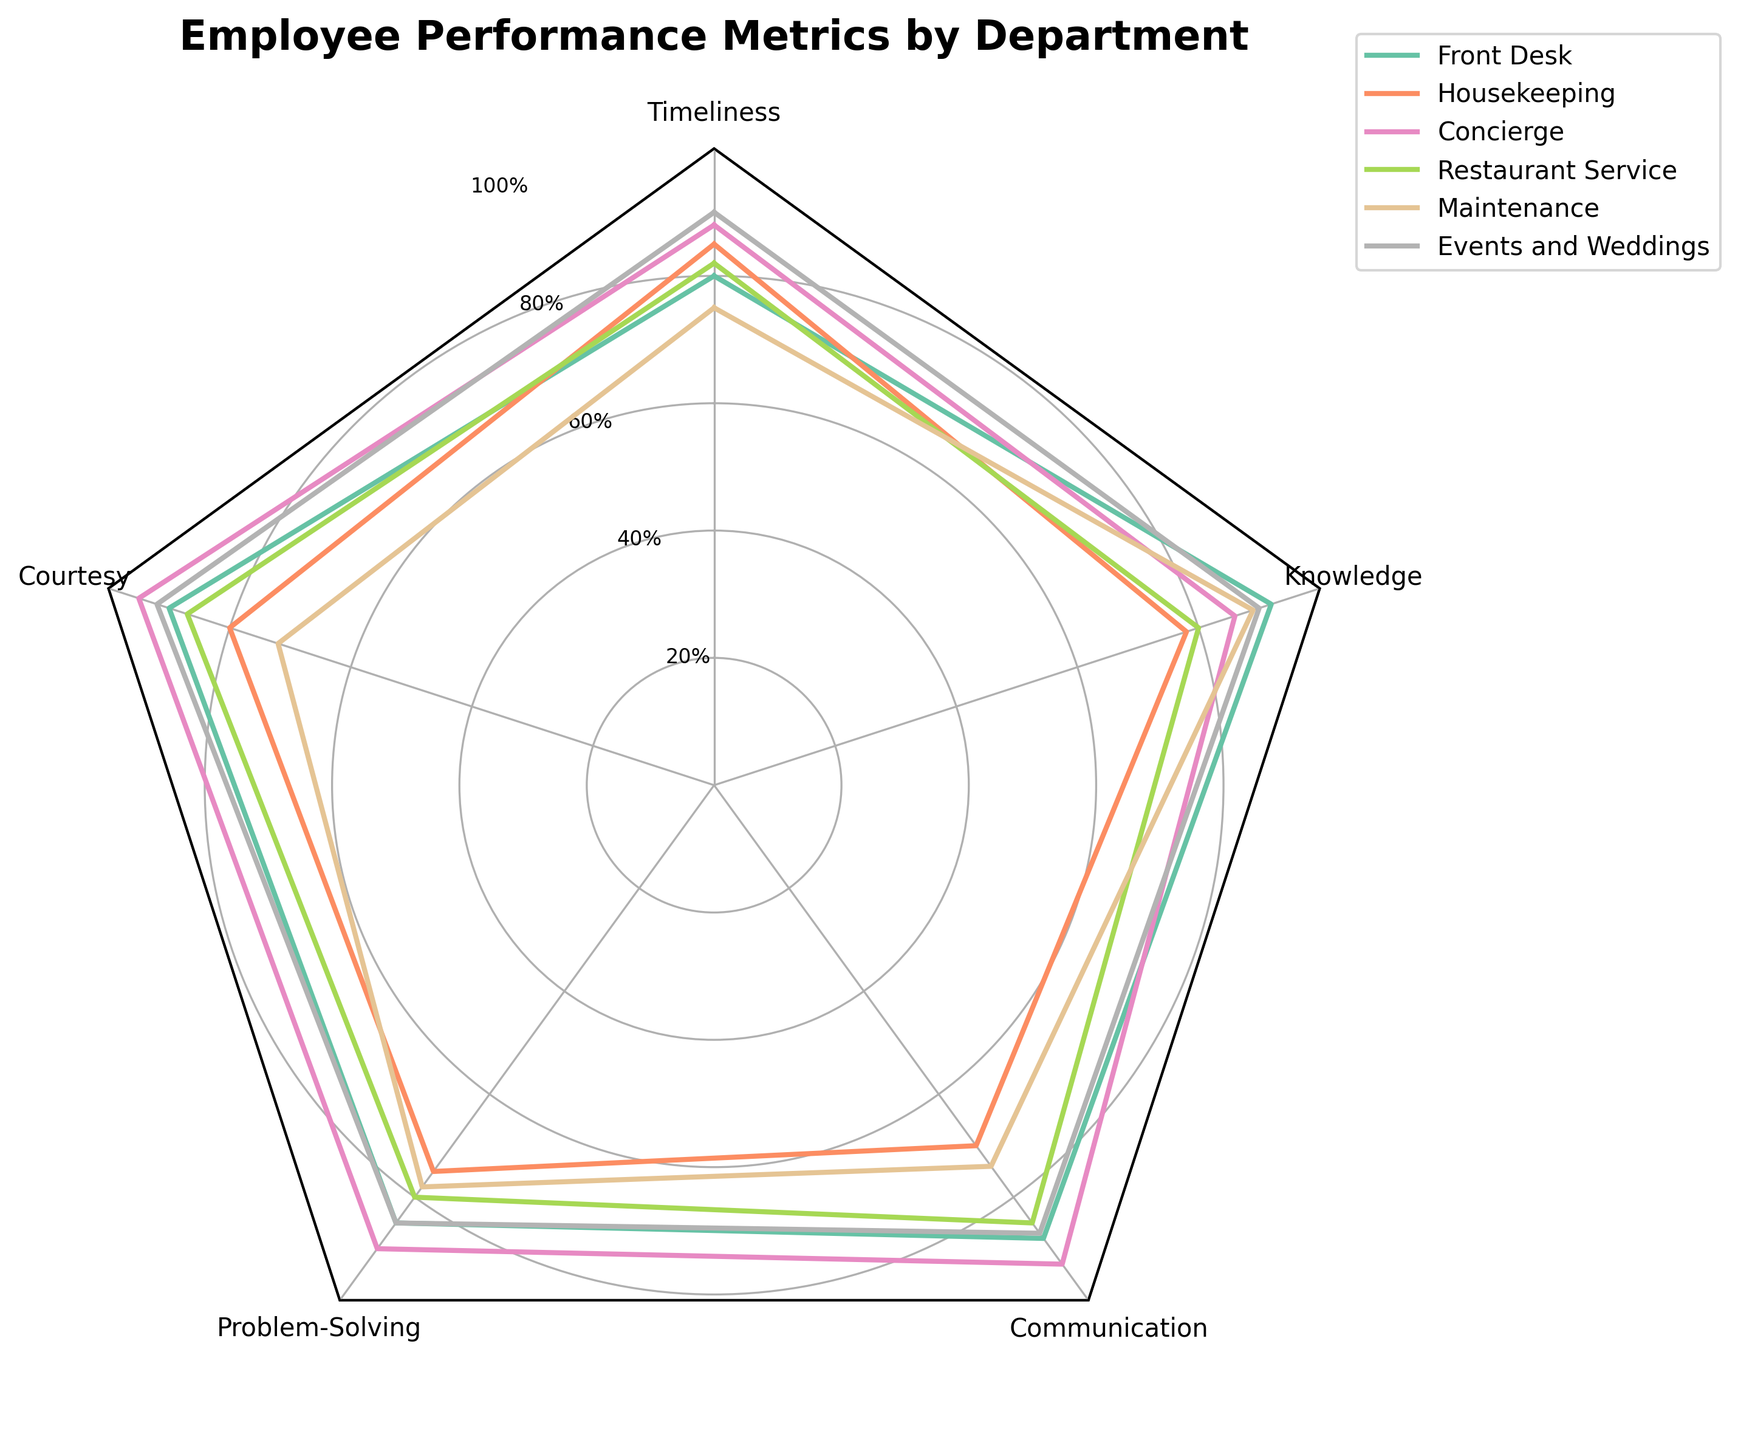What's the title of the figure? The title is displayed at the top of the radar chart. It gives an overview of what the chart is about.
Answer: "Employee Performance Metrics by Department" Which department has the highest score in "Courtesy"? By looking at the "Courtesy" axis, the department with the highest score will have the line extending the furthest.
Answer: Concierge What is the average score of "Knowledge" across all departments? To calculate the average, sum the "Knowledge" scores from all departments and then divide by the number of departments: (92 + 78 + 86 + 80 + 89 + 90) / 6 = 515 / 6.
Answer: 85.83 Which department has the lowest "Problem-Solving" score? Identify the department with the least extension on the "Problem-Solving" axis.
Answer: Housekeeping Compare the "Communication" scores of Front Desk and Restaurant Service. Which is higher? Locate the "Communication" values for both departments and compare them directly: Front Desk = 88, Restaurant Service = 85.
Answer: Front Desk Which two departments have the most similar overall performance? Examine the shapes and areas covered by the respective plots for each department. The most similar plots indicate departments with similar performance metrics.
Answer: Front Desk & Events and Weddings In how many performance metrics does the Front Desk department score above 85? Look at the Front Desk's scores and count the metrics where the values are above 85: Timeliness (80), Courtesy (90), Problem-Solving (85), Communication (88), Knowledge (92)
Answer: 3 What is the difference in "Timeliness" scores between Housekeeping and Maintenance? Find the "Timeliness" values for both departments and calculate the difference: Housekeeping (85) - Maintenance (75) = 10.
Answer: 10 Across how many departments does "Courtesy" score higher than "Problem-Solving"? Compare the "Courtesy" and "Problem-Solving" scores for each department and count the occurrences where "Courtesy" is greater: Front Desk (90 > 85), Housekeeping (80 > 75), Concierge (95 > 90), Restaurant Service (87 > 80), Maintenance (72 < 78), Events and Weddings (92 > 85). Therefore, 5 out of 6 departments meet this criterion.
Answer: 5 Is there any department where "Timeliness" is the lowest scoring metric? Check each department's "Timeliness" score relative to its other metrics: 
   - Front Desk: Timeliness (80), lower than others.
   - Housekeeping: Timeliness (85), not lower than all others.
   - Concierge: Timeliness (88), not lower than all others.
   - Restaurant Service: Timeliness (82), not lower than all others.
   - Maintenance: Timeliness (75), lower than others.
   - Events and Weddings: Timeliness (90), not lower than all others. Only Front Desk and Maintenance have "Timeliness" as the lowest metric.
Answer: Yes 